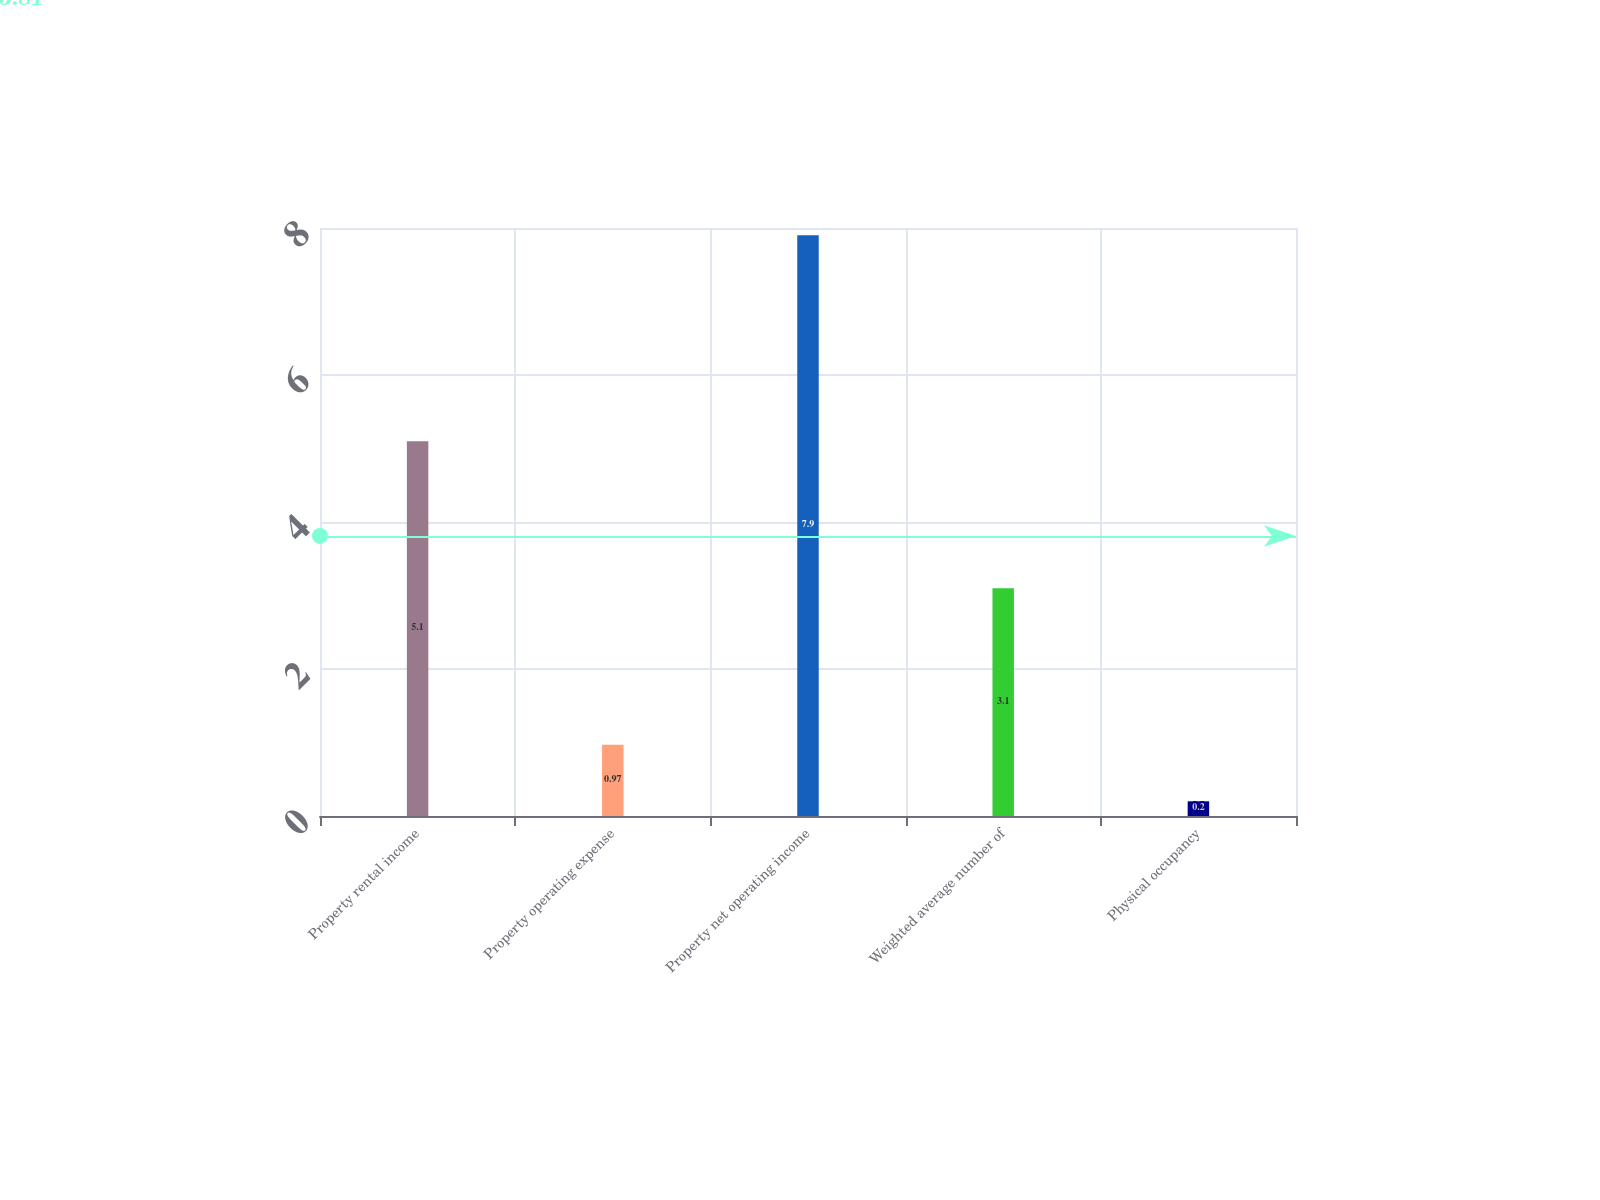Convert chart to OTSL. <chart><loc_0><loc_0><loc_500><loc_500><bar_chart><fcel>Property rental income<fcel>Property operating expense<fcel>Property net operating income<fcel>Weighted average number of<fcel>Physical occupancy<nl><fcel>5.1<fcel>0.97<fcel>7.9<fcel>3.1<fcel>0.2<nl></chart> 